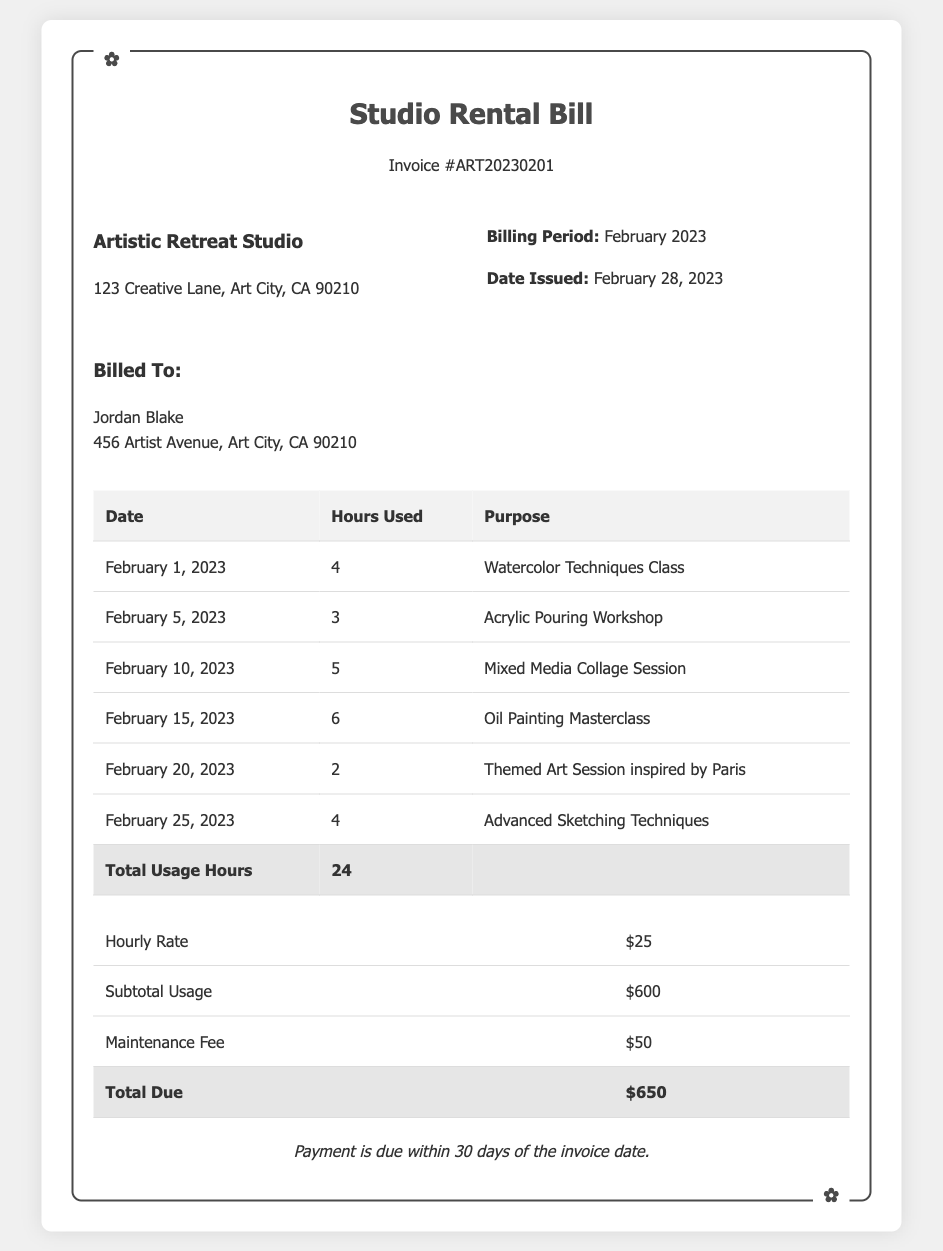what is the name of the studio? The name of the studio is provided at the top of the document under the studio info section.
Answer: Artistic Retreat Studio what is the total usage hours? The total usage hours are calculated and shown in the table under the total row.
Answer: 24 what is the hourly rate? The hourly rate is specified in the financial breakdown table in the document.
Answer: $25 who is the bill issued to? The recipient's name is mentioned in the client info section of the document.
Answer: Jordan Blake what is the maintenance fee? The maintenance fee is listed in the total financial breakdown section of the document.
Answer: $50 how many hours were used for the Oil Painting Masterclass? The hours used for the Oil Painting Masterclass is indicated next to the respective date in the usage table.
Answer: 6 when was the bill issued? The date of issue of the bill is clearly indicated in the billing period section of the document.
Answer: February 28, 2023 what is the subtotal usage? The subtotal usage is found in the financial section of the document under the respective label.
Answer: $600 how many sessions took place in February? The number of sessions can be counted from the table that lists each session along with the date.
Answer: 6 